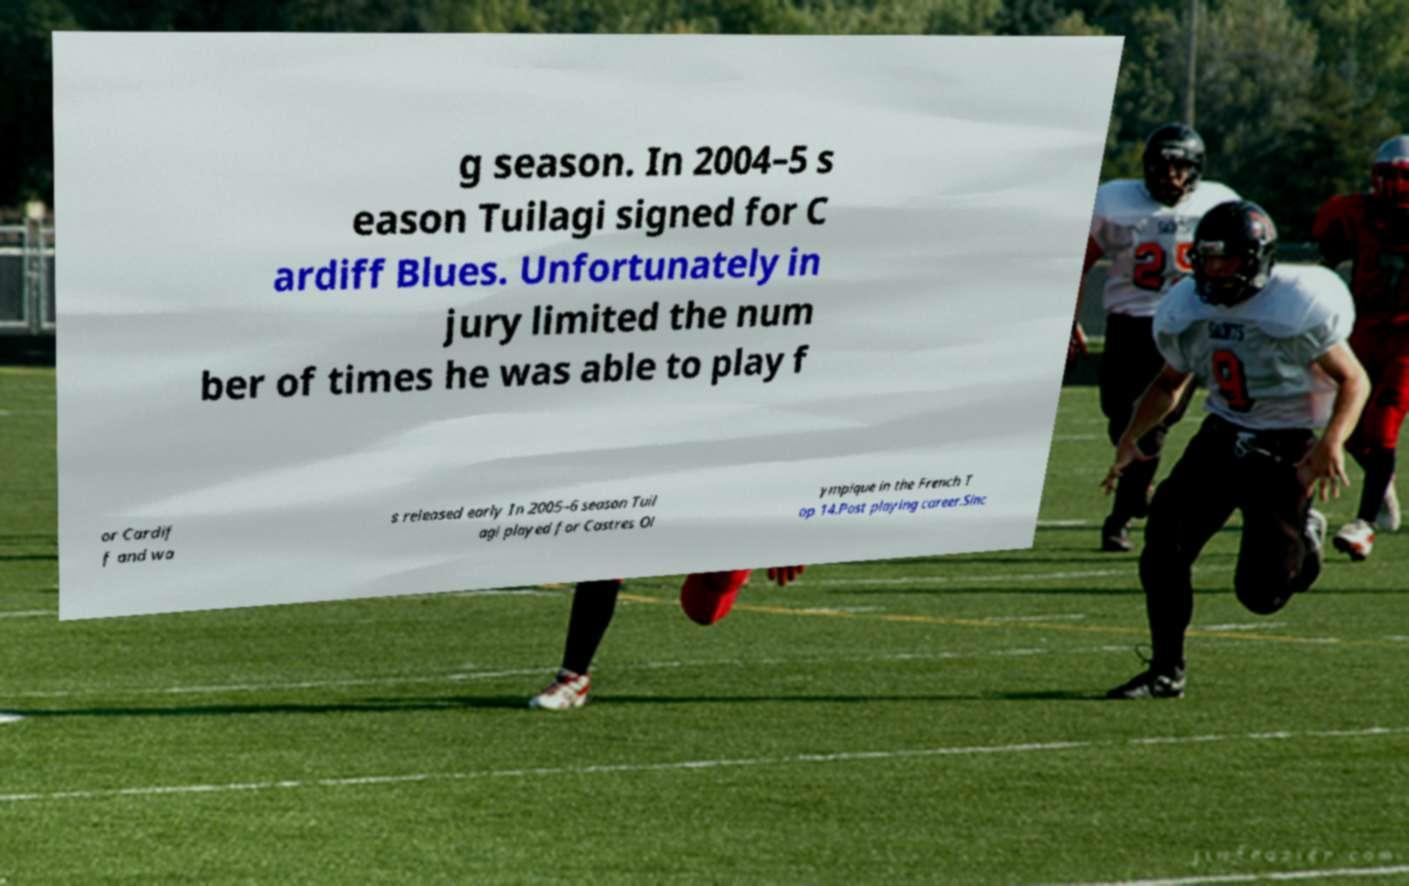Could you extract and type out the text from this image? g season. In 2004–5 s eason Tuilagi signed for C ardiff Blues. Unfortunately in jury limited the num ber of times he was able to play f or Cardif f and wa s released early In 2005–6 season Tuil agi played for Castres Ol ympique in the French T op 14.Post playing career.Sinc 